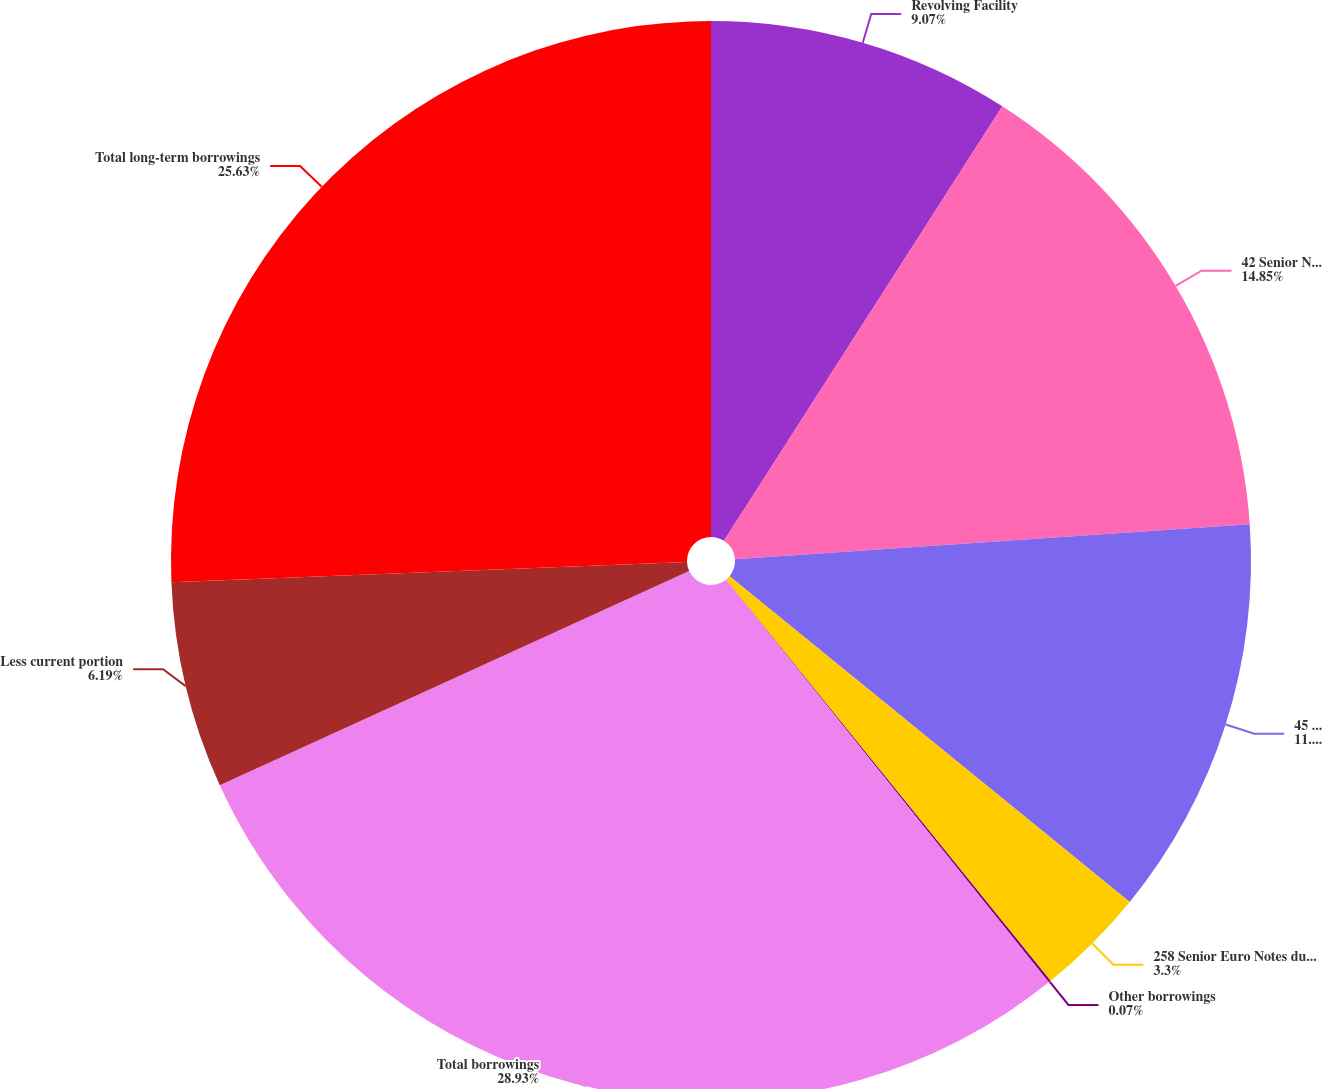Convert chart. <chart><loc_0><loc_0><loc_500><loc_500><pie_chart><fcel>Revolving Facility<fcel>42 Senior Notes due December<fcel>45 Senior Notes due December<fcel>258 Senior Euro Notes due June<fcel>Other borrowings<fcel>Total borrowings<fcel>Less current portion<fcel>Total long-term borrowings<nl><fcel>9.07%<fcel>14.85%<fcel>11.96%<fcel>3.3%<fcel>0.07%<fcel>28.94%<fcel>6.19%<fcel>25.63%<nl></chart> 